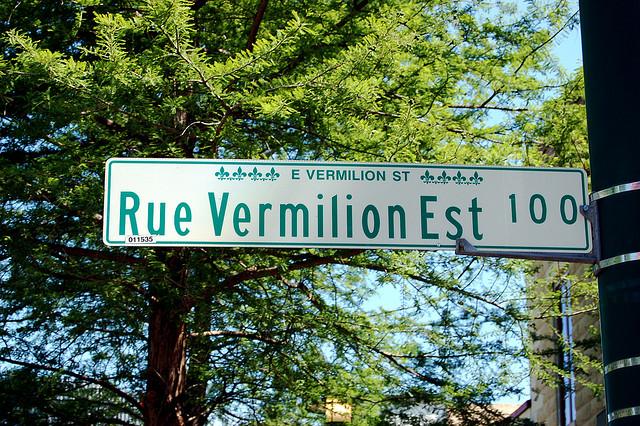What is city is this?
Quick response, please. Paris. What letter is repeated in the street sign's name?
Answer briefly. E. What does this word mean?
Write a very short answer. Street. What does the street sign say?
Give a very brief answer. Rue vermilion est 100. What city was this taken in?
Be succinct. Vermilion. What is on the sign?
Be succinct. Rue vermilion est 100. Is there a tree behind the sign?
Give a very brief answer. Yes. What number is on the sign?
Give a very brief answer. 100. What are the numbers on the sign?
Write a very short answer. 100. What color is the writing on the sign?
Short answer required. Green. What does this sign say?
Write a very short answer. Rue vermilion est 100. Is this the USA?
Quick response, please. No. 